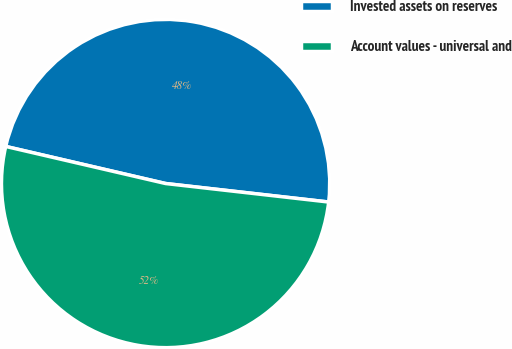<chart> <loc_0><loc_0><loc_500><loc_500><pie_chart><fcel>Invested assets on reserves<fcel>Account values - universal and<nl><fcel>48.17%<fcel>51.83%<nl></chart> 